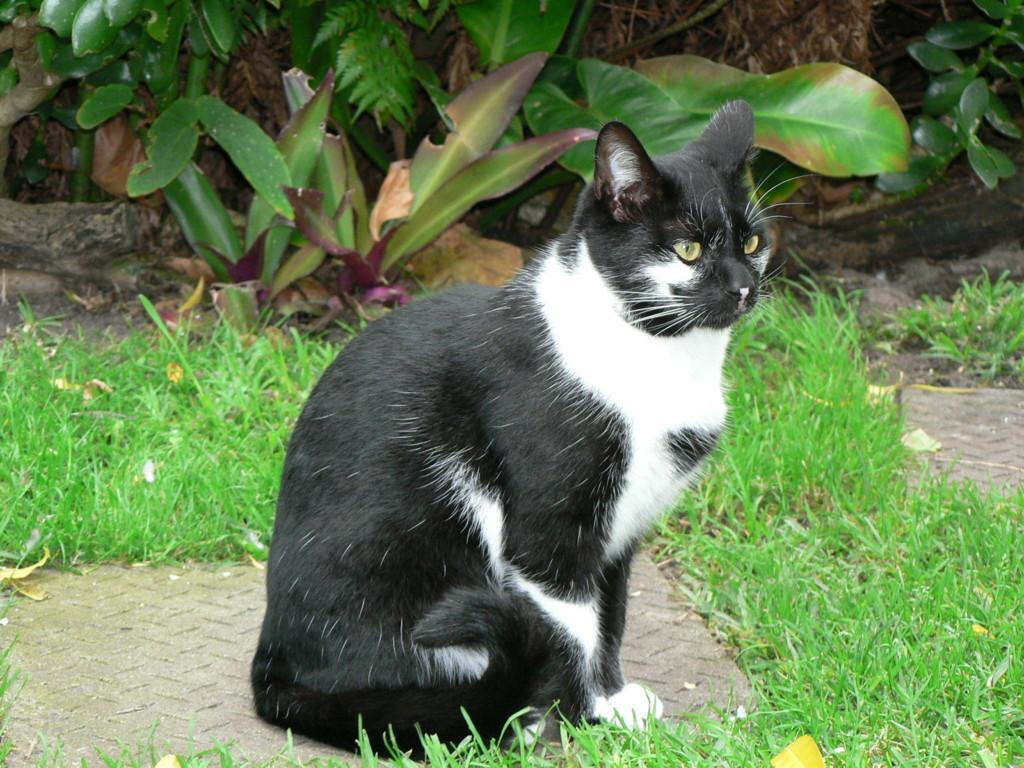What type of surface is visible on the ground in the image? There is grass on the ground in the image. What animal is in the center of the image? There is a cat in the center of the image. What can be seen in the background of the image? There are plants in the background of the image. What type of eggs can be seen in the image? There are no eggs present in the image. Is the cat accompanied by a dog in the image? There is no dog present in the image; only a cat is visible. 